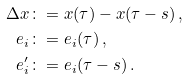Convert formula to latex. <formula><loc_0><loc_0><loc_500><loc_500>\Delta x & \colon = x ( \tau ) - x ( \tau - s ) \ , \\ e _ { i } & \colon = e _ { i } ( \tau ) \ , \\ e ^ { \prime } _ { i } & \colon = e _ { i } ( \tau - s ) \ .</formula> 